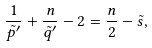Convert formula to latex. <formula><loc_0><loc_0><loc_500><loc_500>\frac { 1 } { \tilde { p } ^ { \prime } } + \frac { n } { \tilde { q } ^ { \prime } } - 2 = \frac { n } { 2 } - \tilde { s } ,</formula> 